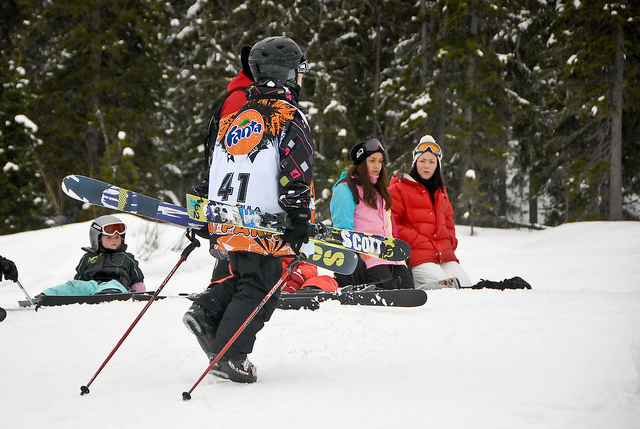Identify the text contained in this image. FANTA 47 SCOTT S 